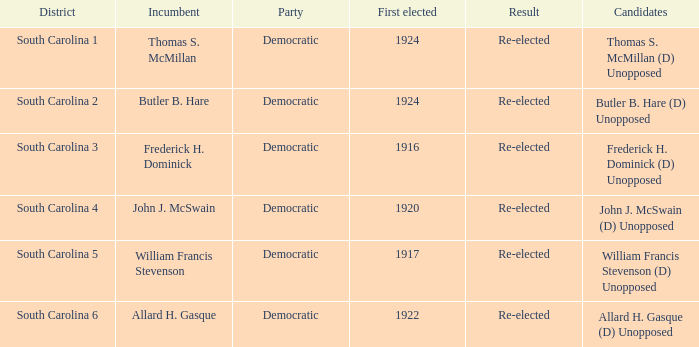Who is the contender in district south carolina 2? Butler B. Hare (D) Unopposed. 